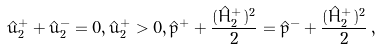<formula> <loc_0><loc_0><loc_500><loc_500>\hat { u } _ { 2 } ^ { + } + \hat { u } _ { 2 } ^ { - } = 0 , \hat { u } _ { 2 } ^ { + } > 0 , \hat { p } ^ { + } + \frac { ( \hat { H } ^ { + } _ { 2 } ) ^ { 2 } } { 2 } = \hat { p } ^ { - } + \frac { ( \hat { H } ^ { + } _ { 2 } ) ^ { 2 } } { 2 } \, ,</formula> 